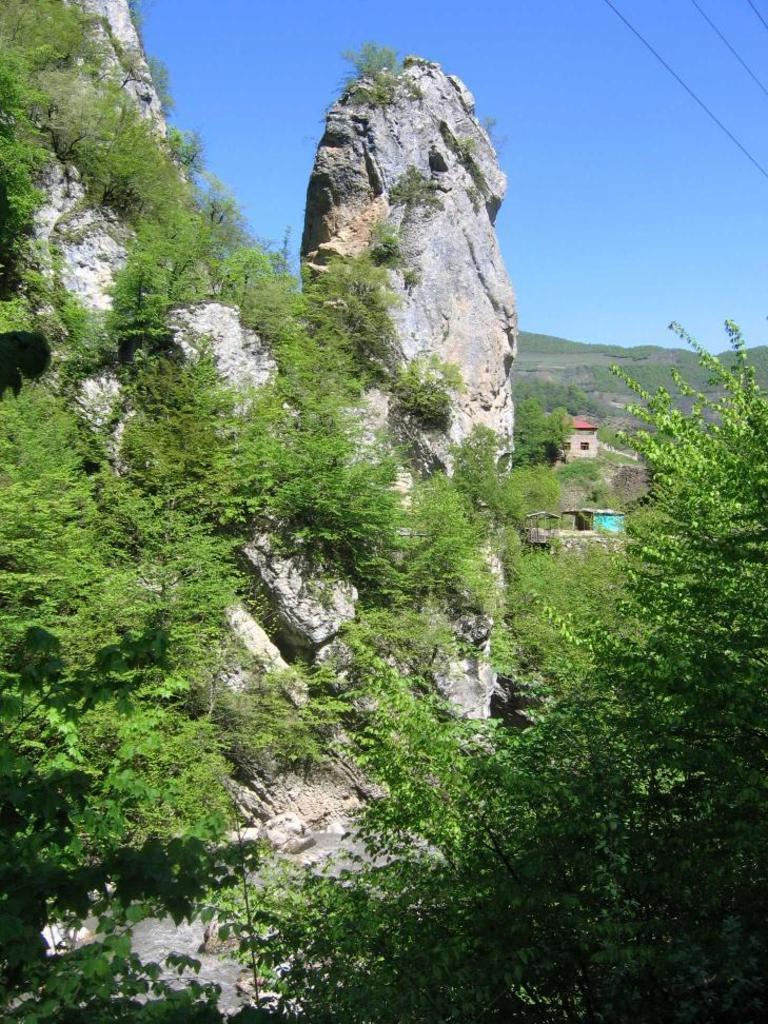Describe this image in one or two sentences. In this picture, there is a rock in the middle and plants on the right side and in the background it is the sky. 